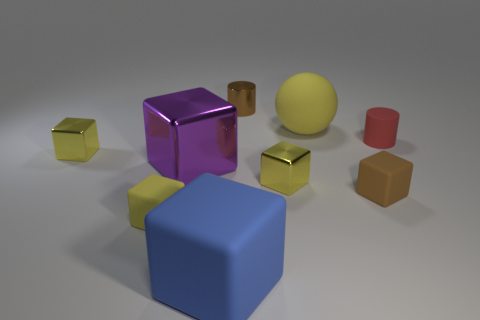There is a matte block that is both right of the large metal object and left of the brown shiny cylinder; what is its color?
Your response must be concise. Blue. Is the material of the large blue block the same as the large purple cube?
Keep it short and to the point. No. What number of tiny objects are either blue things or red rubber spheres?
Keep it short and to the point. 0. Is there anything else that has the same shape as the big yellow matte thing?
Ensure brevity in your answer.  No. What is the color of the cylinder that is made of the same material as the large purple thing?
Provide a succinct answer. Brown. The tiny metal object behind the big yellow matte object is what color?
Offer a very short reply. Brown. How many rubber cubes are the same color as the metal cylinder?
Your answer should be very brief. 1. Are there fewer yellow matte balls on the right side of the big yellow sphere than yellow matte objects in front of the tiny red matte thing?
Your response must be concise. Yes. There is a purple metallic object; what number of small shiny blocks are in front of it?
Your answer should be compact. 1. Are there any big purple things that have the same material as the small brown cube?
Your answer should be compact. No. 